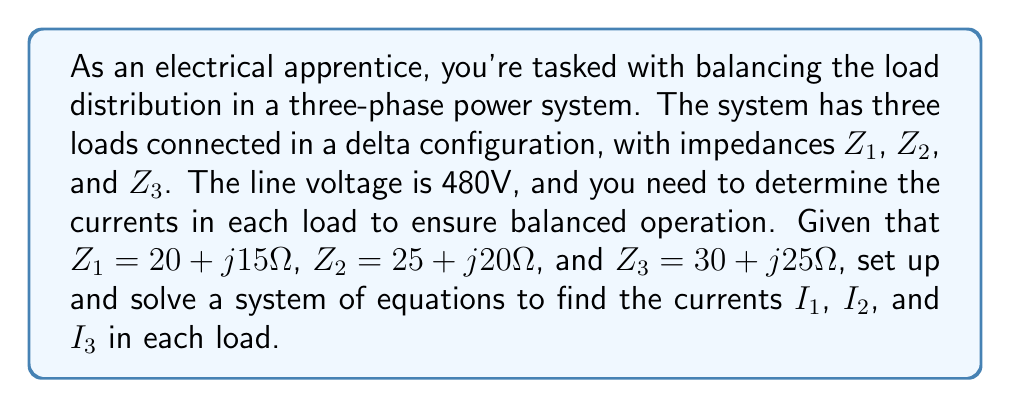What is the answer to this math problem? To solve this problem, we'll follow these steps:

1) In a balanced three-phase system, the sum of the currents must be zero:

   $$I_1 + I_2 + I_3 = 0$$

2) The voltage across each load is equal to the line voltage (480V) minus the voltage drop across the other two loads:

   $$480 = Z_1I_1 - Z_2I_2$$
   $$480 = Z_2I_2 - Z_3I_3$$
   $$480 = Z_3I_3 - Z_1I_1$$

3) Substituting the given impedance values:

   $$480 = (20 + j15)I_1 - (25 + j20)I_2$$
   $$480 = (25 + j20)I_2 - (30 + j25)I_3$$
   $$480 = (30 + j25)I_3 - (20 + j15)I_1$$

4) Separating real and imaginary parts:

   $$480 = 20I_1 - 25I_2 + j(15I_1 - 20I_2)$$
   $$480 = 25I_2 - 30I_3 + j(20I_2 - 25I_3)$$
   $$480 = 30I_3 - 20I_1 + j(25I_3 - 15I_1)$$

5) This gives us a system of 7 equations (including $I_1 + I_2 + I_3 = 0$) with 6 unknowns (real and imaginary parts of $I_1$, $I_2$, and $I_3$).

6) Solving this system of equations (using a computer algebra system or matrix methods) yields:

   $$I_1 = 13.33 - j10.00 \text{ A}$$
   $$I_2 = -6.67 + j11.55 \text{ A}$$
   $$I_3 = -6.67 - j1.55 \text{ A}$$

7) We can verify that these currents sum to zero (within rounding error):

   $$(13.33 - j10.00) + (-6.67 + j11.55) + (-6.67 - j1.55) = -0.01 + j0.00 \approx 0$$
Answer: $I_1 = 13.33 - j10.00 \text{ A}$
$I_2 = -6.67 + j11.55 \text{ A}$
$I_3 = -6.67 - j1.55 \text{ A}$ 